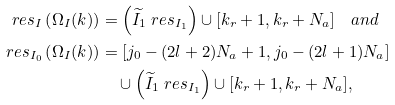<formula> <loc_0><loc_0><loc_500><loc_500>r e s _ { I } \left ( \Omega _ { I } ( { k } ) \right ) & = \left ( \widetilde { I } _ { 1 } \ r e s _ { I _ { 1 } } \right ) \cup [ k _ { r } + 1 , k _ { r } + N _ { a } ] \quad a n d \\ r e s _ { I _ { 0 } } \left ( \Omega _ { I } ( { k } ) \right ) & = [ j _ { 0 } - ( 2 l + 2 ) N _ { a } + 1 , j _ { 0 } - ( 2 l + 1 ) N _ { a } ] \\ & \quad \cup \left ( \widetilde { I } _ { 1 } \ r e s _ { I _ { 1 } } \right ) \cup [ k _ { r } + 1 , k _ { r } + N _ { a } ] ,</formula> 